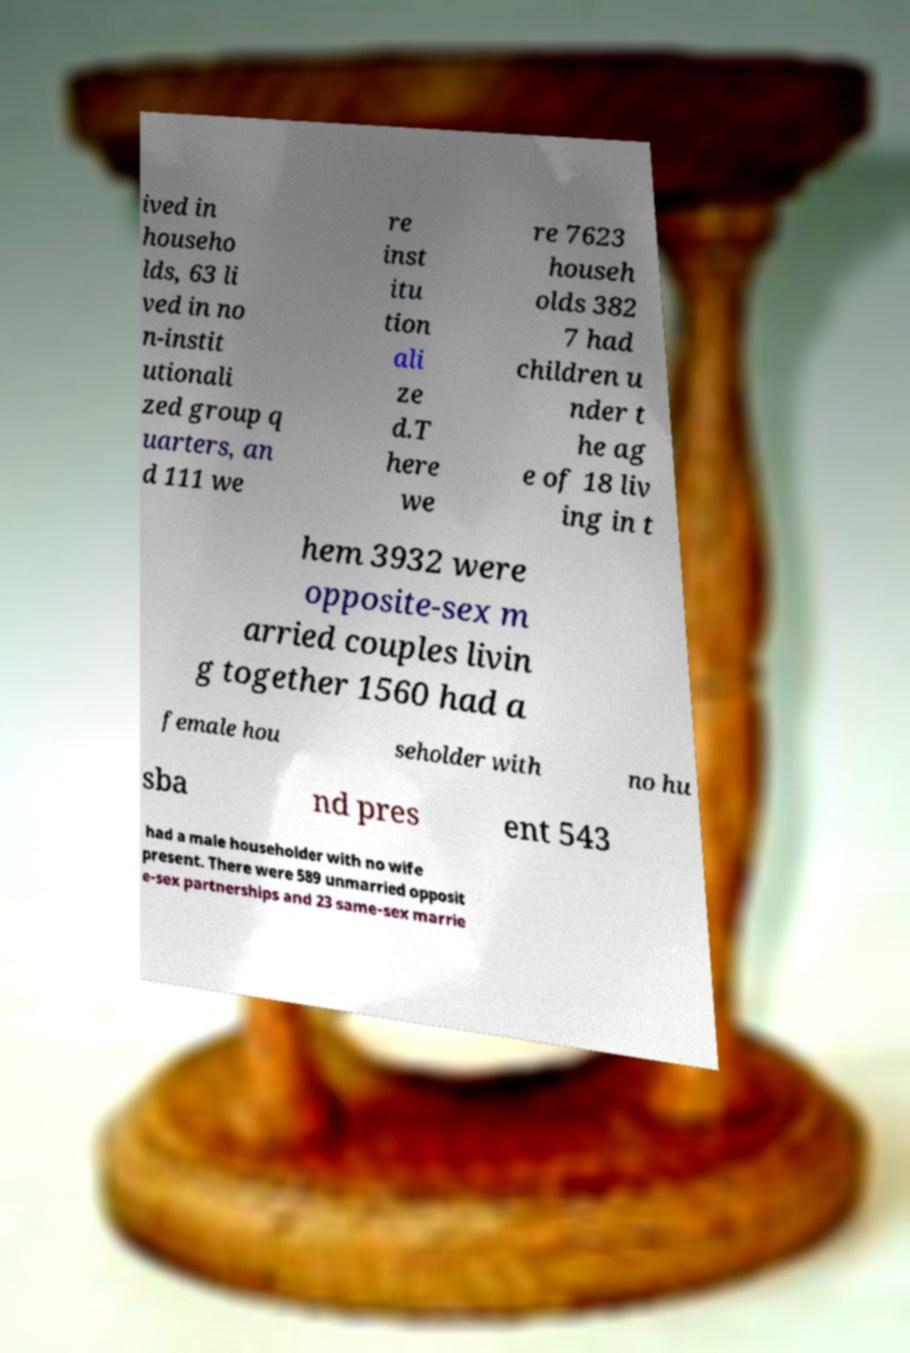Please identify and transcribe the text found in this image. ived in househo lds, 63 li ved in no n-instit utionali zed group q uarters, an d 111 we re inst itu tion ali ze d.T here we re 7623 househ olds 382 7 had children u nder t he ag e of 18 liv ing in t hem 3932 were opposite-sex m arried couples livin g together 1560 had a female hou seholder with no hu sba nd pres ent 543 had a male householder with no wife present. There were 589 unmarried opposit e-sex partnerships and 23 same-sex marrie 